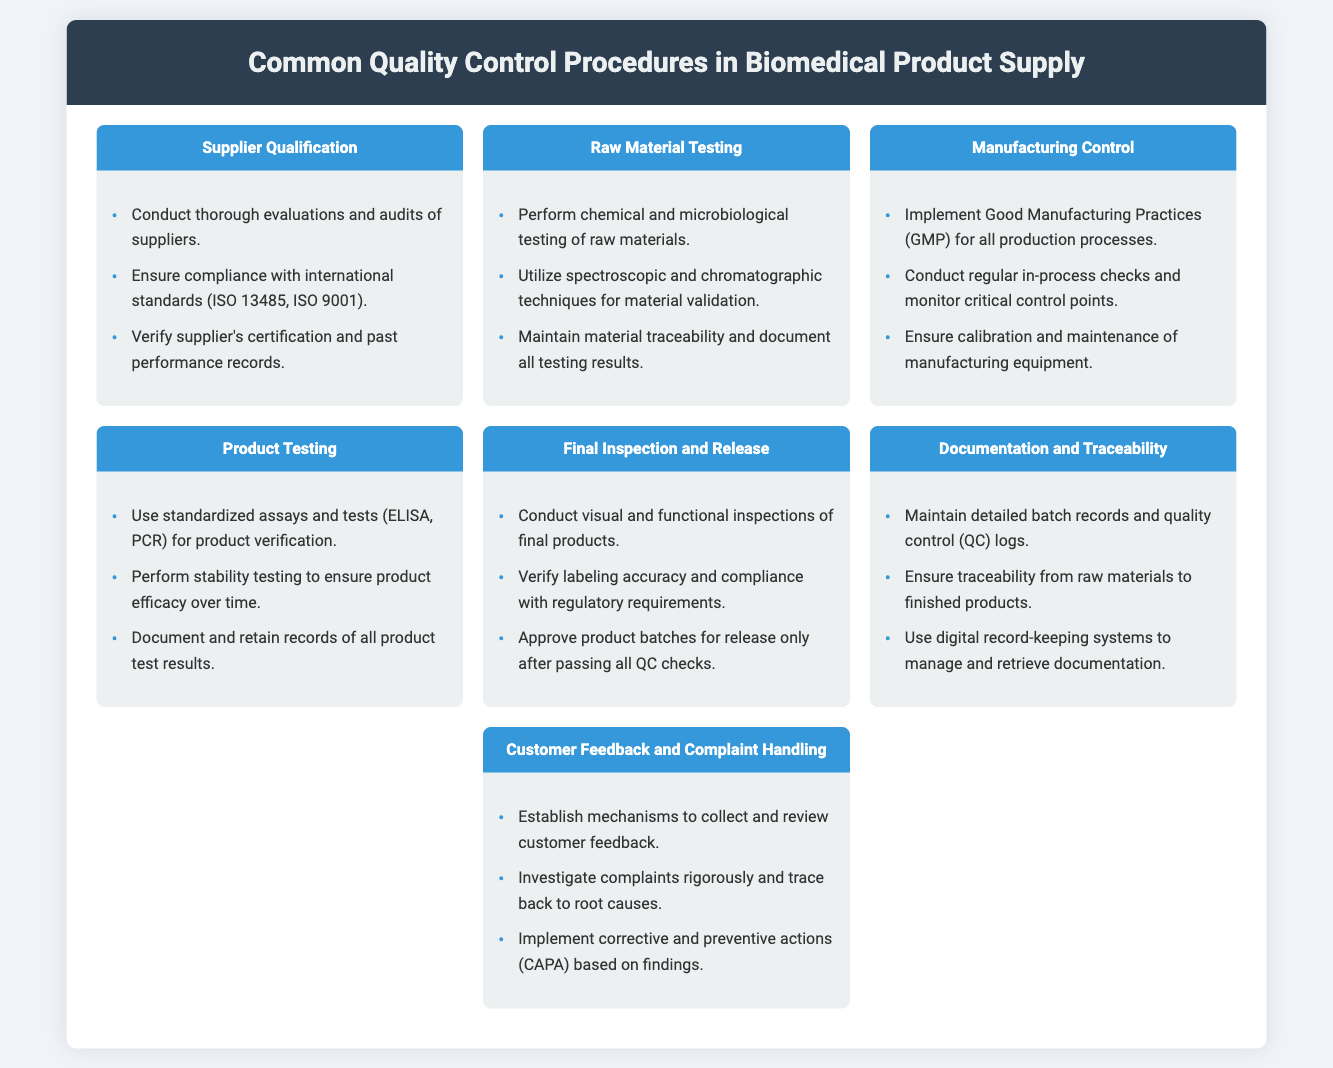What is the first control procedure listed? The first control procedure mentioned in the document is related to the evaluation of suppliers, specifically "Supplier Qualification."
Answer: Supplier Qualification How many quality control procedures are listed in the infographic? There are seven different quality control procedures presented in the document.
Answer: Seven What is one method used for raw material testing? The document mentions spectroscopic techniques as a method for raw material testing.
Answer: Spectroscopic techniques Which procedure emphasizes compliance with regulatory requirements? The "Final Inspection and Release" procedure highlights the importance of compliance with regulatory requirements.
Answer: Final Inspection and Release What does CAPA stand for in the context of customer feedback? CAPA stands for Corrective and Preventive Actions, as stated in the document under the customer feedback section.
Answer: Corrective and Preventive Actions What type of inspections are conducted on final products? The document specifies both visual and functional inspections are performed on final products.
Answer: Visual and functional inspections Which procedure involves maintaining detailed batch records? "Documentation and Traceability" involves maintaining detailed batch records and quality control logs.
Answer: Documentation and Traceability What is the main objective of manufacturing control? The main objective of manufacturing control is to implement Good Manufacturing Practices (GMP).
Answer: Good Manufacturing Practices 